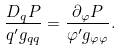Convert formula to latex. <formula><loc_0><loc_0><loc_500><loc_500>\frac { D _ { q } P } { q ^ { \prime } g _ { q q } } = \frac { \partial _ { \varphi } P } { \varphi ^ { \prime } g _ { \varphi \varphi } } .</formula> 